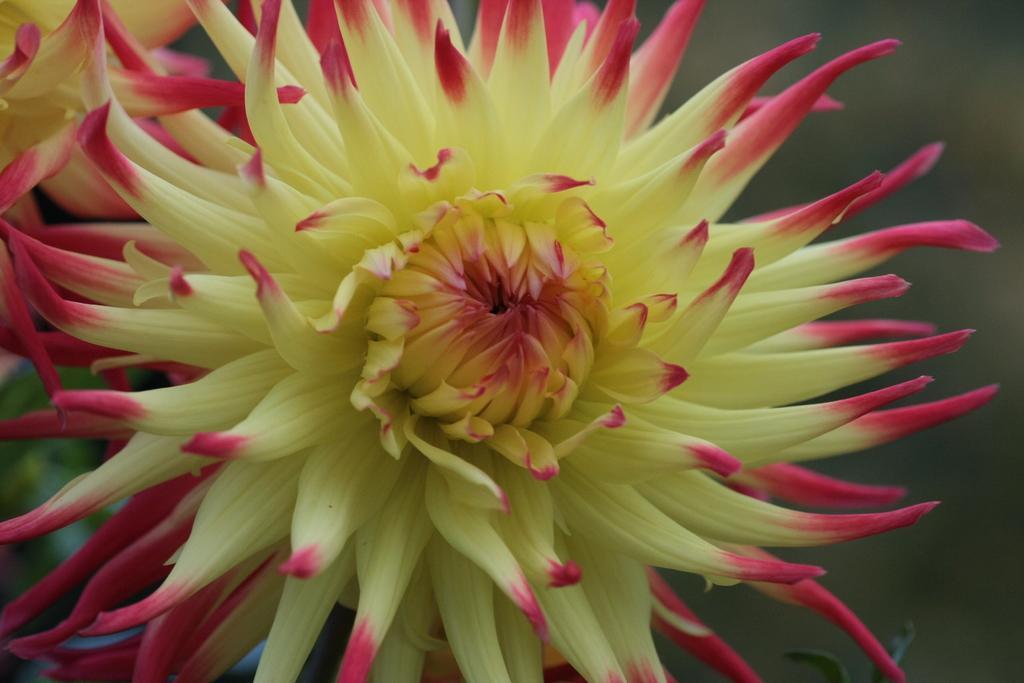Describe this image in one or two sentences. In the center of this picture we can see the flowers. In the background we can see the green leaves and some other objects. 